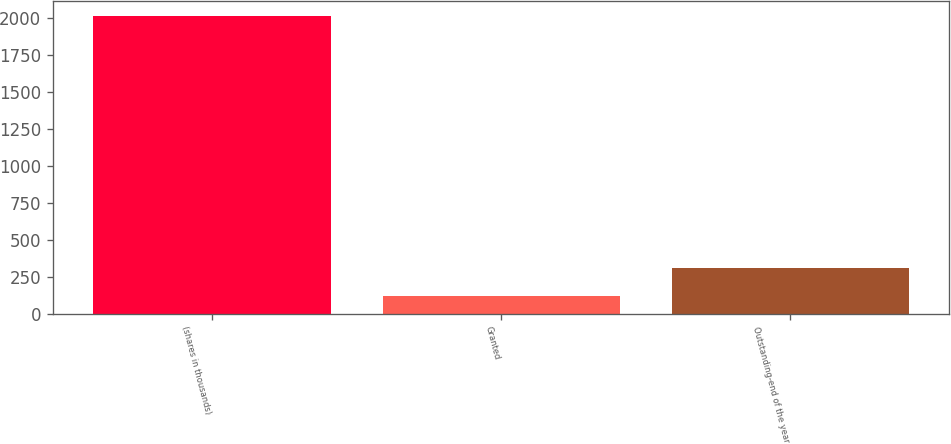<chart> <loc_0><loc_0><loc_500><loc_500><bar_chart><fcel>(shares in thousands)<fcel>Granted<fcel>Outstanding-end of the year<nl><fcel>2011<fcel>120<fcel>309.1<nl></chart> 